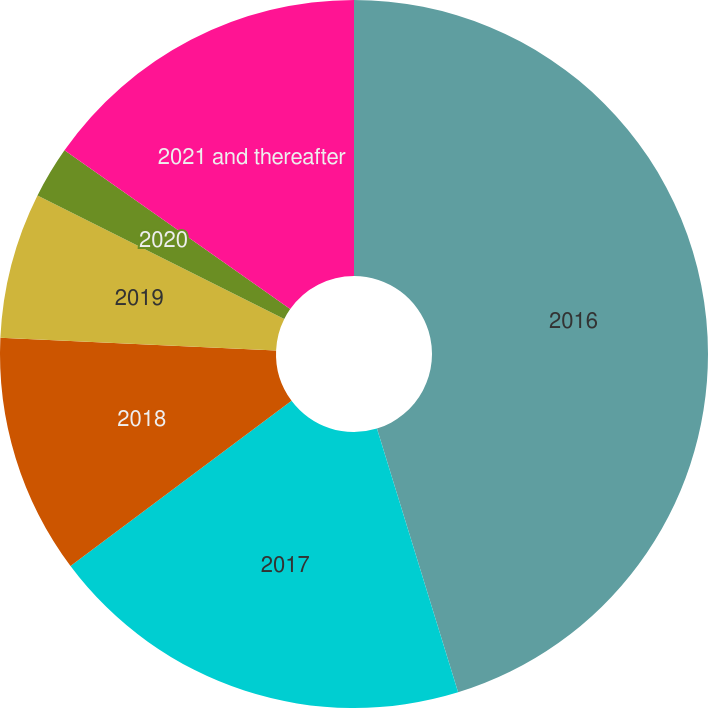Convert chart to OTSL. <chart><loc_0><loc_0><loc_500><loc_500><pie_chart><fcel>2016<fcel>2017<fcel>2018<fcel>2019<fcel>2020<fcel>2021 and thereafter<nl><fcel>45.25%<fcel>19.53%<fcel>10.95%<fcel>6.66%<fcel>2.37%<fcel>15.24%<nl></chart> 